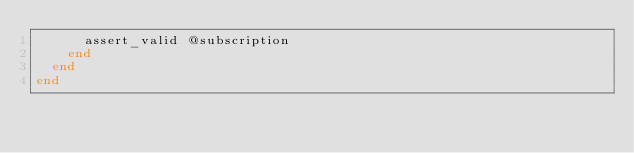<code> <loc_0><loc_0><loc_500><loc_500><_Ruby_>      assert_valid @subscription
    end
  end
end
</code> 